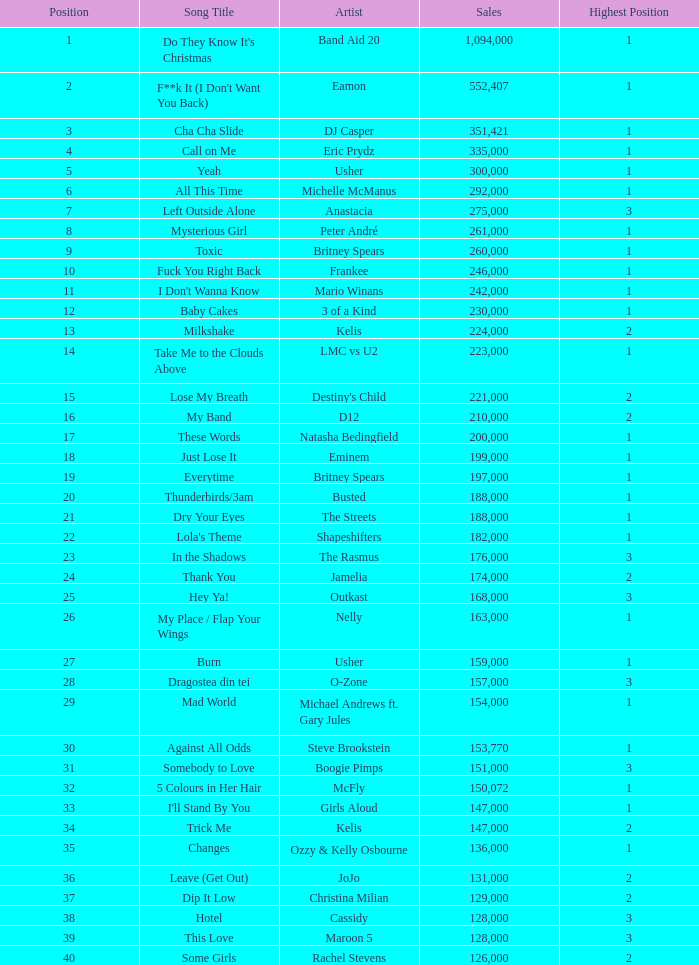What is the highest sales for a song ranked above 3? None. 